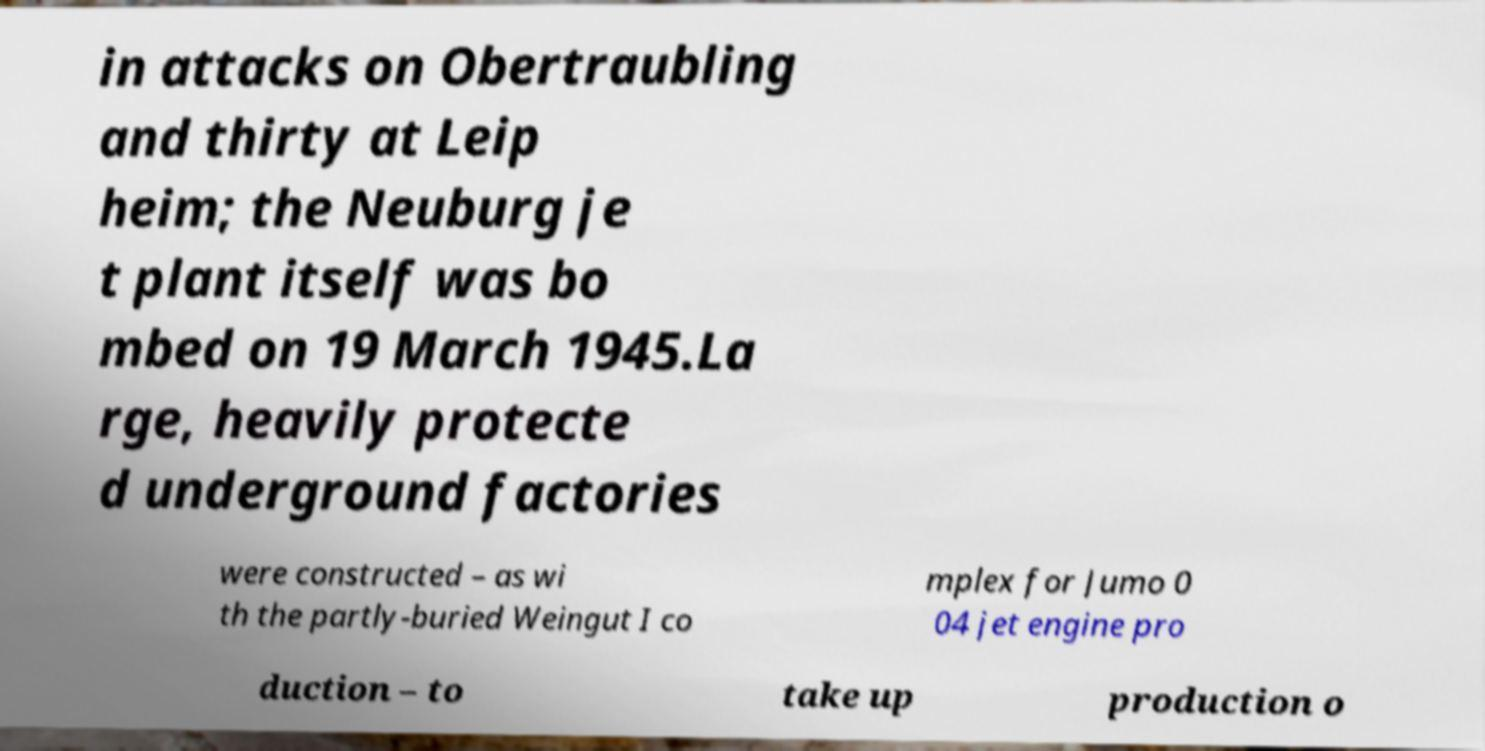Could you assist in decoding the text presented in this image and type it out clearly? in attacks on Obertraubling and thirty at Leip heim; the Neuburg je t plant itself was bo mbed on 19 March 1945.La rge, heavily protecte d underground factories were constructed – as wi th the partly-buried Weingut I co mplex for Jumo 0 04 jet engine pro duction – to take up production o 